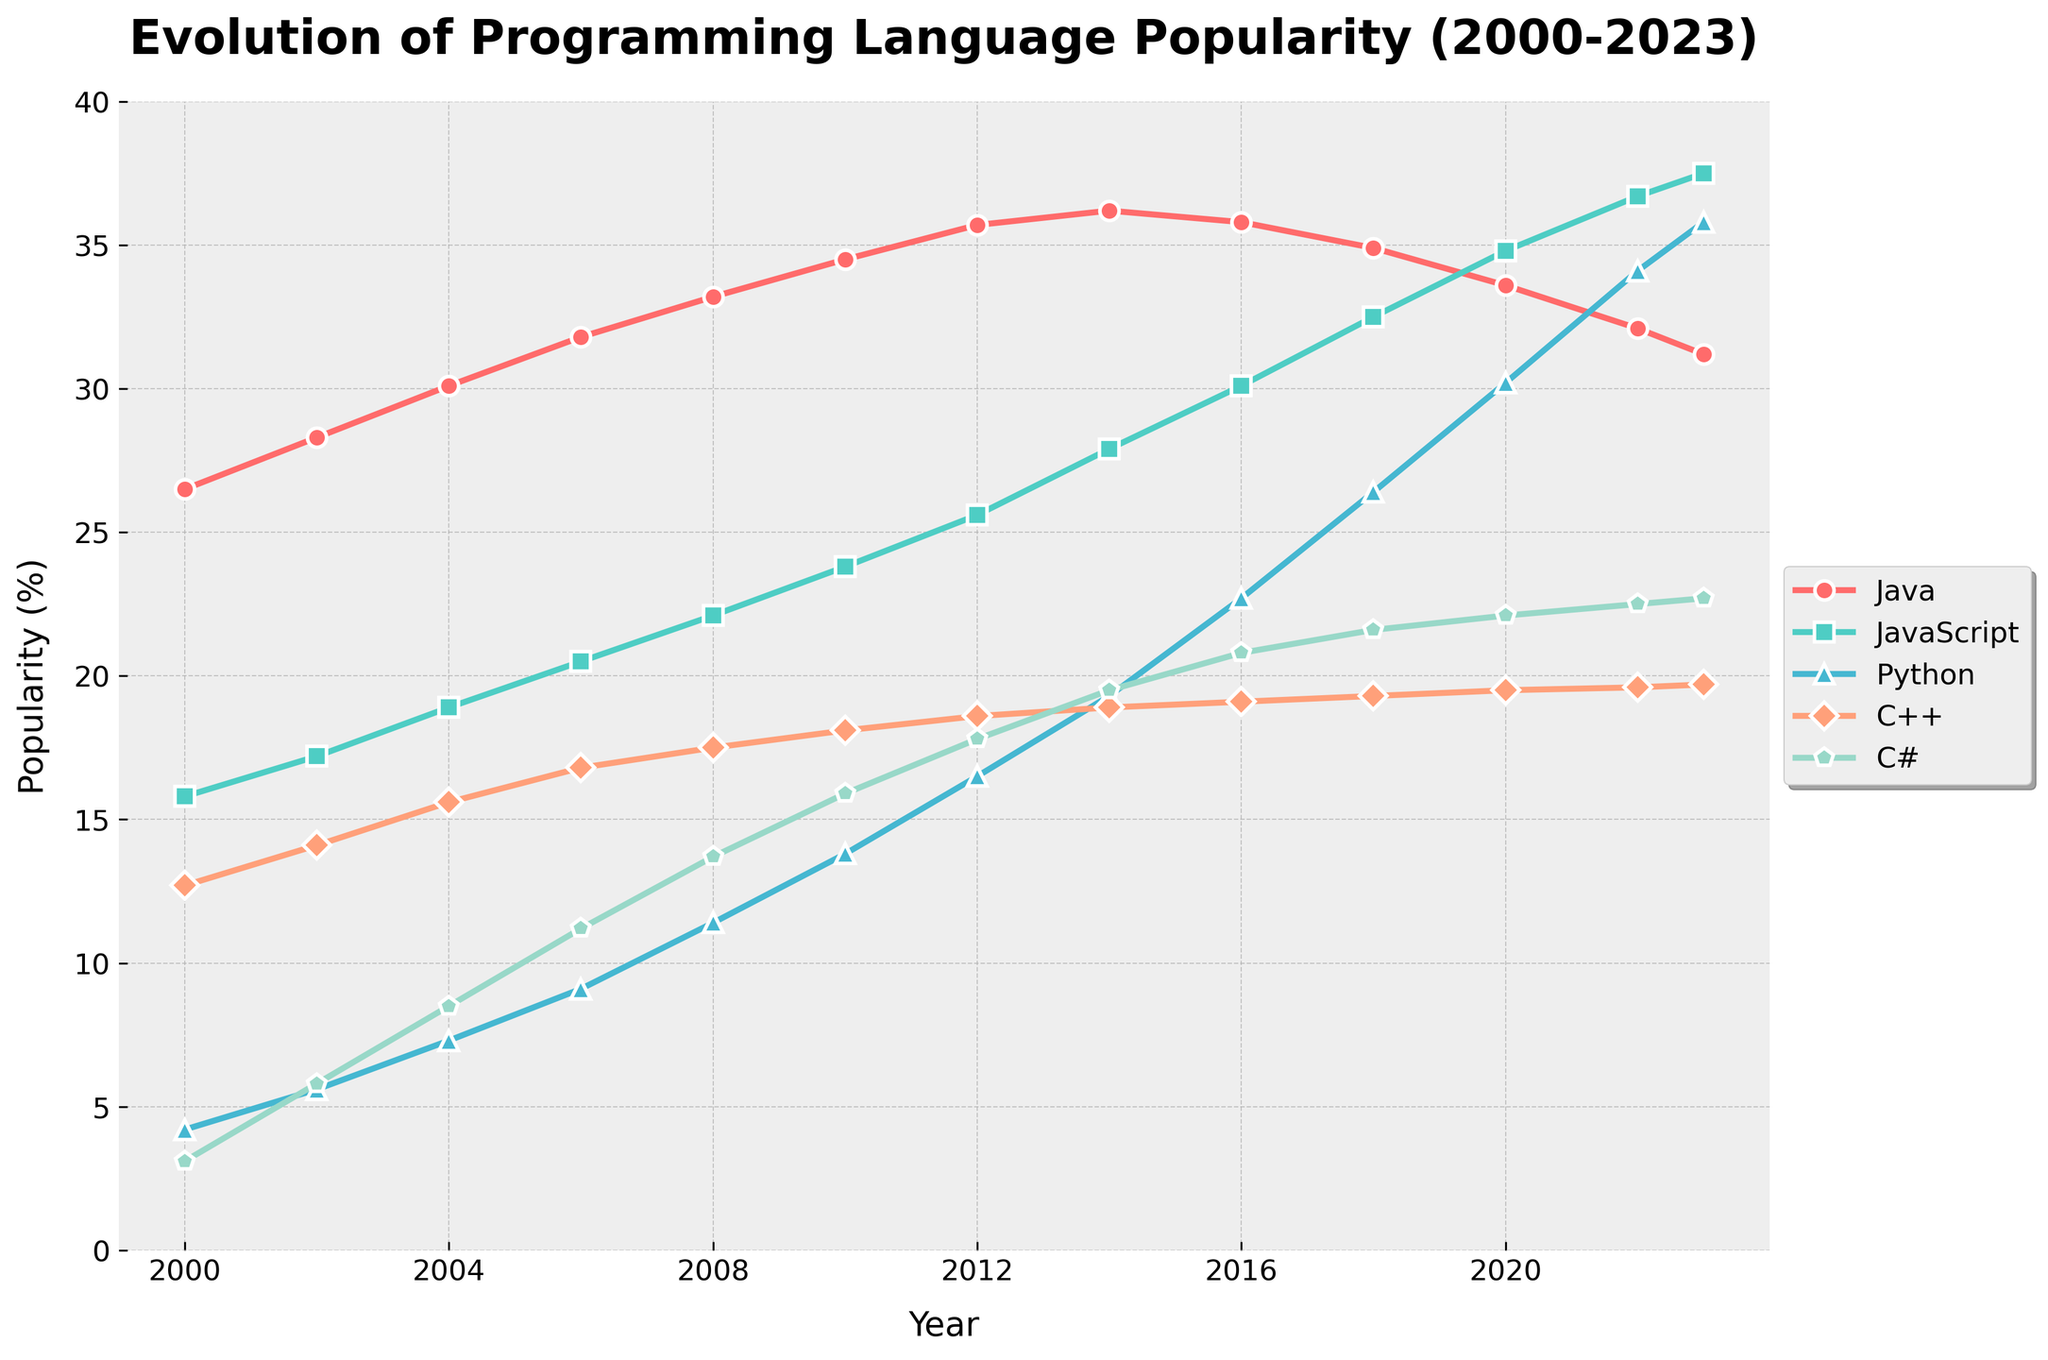How has the popularity of JavaScript and Python evolved from 2000 to 2023? JavaScript and Python both increased significantly in popularity over time. In 2000, JavaScript was at 15.8%, and Python was at 4.2%. By 2023, JavaScript had reached 37.5%, and Python had reached 35.8%.
Answer: JavaScript and Python both increased significantly What year did Python's popularity surpass Java's popularity? Python's popularity surpassed Java's popularity between 2020 and 2022. In 2020, Java was at 33.6% and Python at 30.2%. By 2022, Python had reached 34.1% while Java was down to 32.1%.
Answer: Between 2020 and 2022 Which programming language had the most consistent increase in popularity from 2000 to 2023? Python had the most consistent increase in popularity. Its popularity rose steadily from 4.2% in 2000 to 35.8% in 2023.
Answer: Python Which year did C# surpass C++ in popularity, and how long has it remained more popular? C# surpassed C++ in popularity around 2014. C# was at 19.5% while C++ was at 18.9% that year. C# has remained more popular than C++ for roughly 9 years, from 2014 to 2023.
Answer: 2014, 9 years What is the total increase in popularity for Python from 2000 to 2023? The popularity of Python increased from 4.2% in 2000 to 35.8% in 2023. The total increase is 35.8% - 4.2% = 31.6%.
Answer: 31.6% In which decade did JavaScript see the largest growth in popularity? JavaScript saw the largest growth from 2000 to 2010. Its popularity went from 15.8% in 2000 to 23.8% in 2010, an increase of 23.8% - 15.8% = 8%.
Answer: 2000 to 2010 Compare the popularity trends of C++ and C# between 2006 and 2023. Between 2006 and 2023, C++ shows a relatively stable trend, starting at 16.8% in 2006 and ending with 19.7% in 2023. C# shows a steady increase, from 11.2% in 2006 to 22.7% in 2023.
Answer: C++ stable, C# steady increase Which language had the highest peak popularity, and in which year did this occur? Java had the highest peak popularity at 36.2% in 2014, followed by JavaScript at 37.5% in 2023.
Answer: JavaScript, 2023 